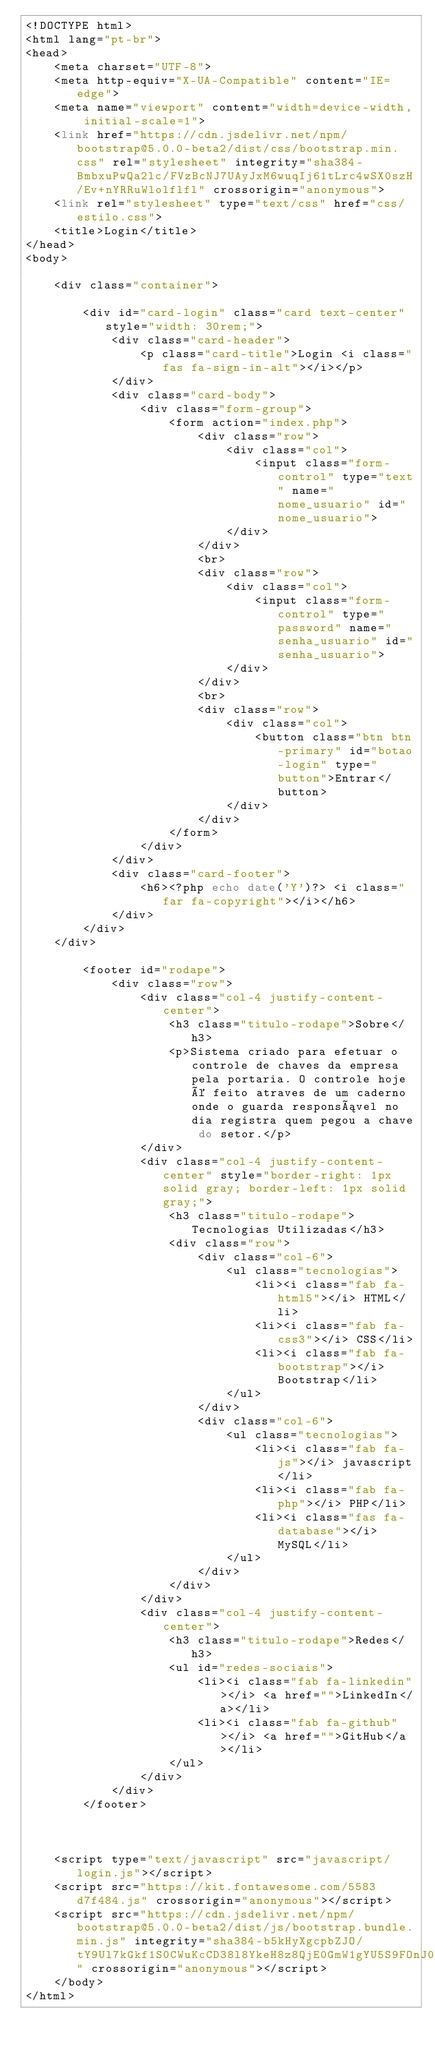Convert code to text. <code><loc_0><loc_0><loc_500><loc_500><_PHP_><!DOCTYPE html>
<html lang="pt-br">
<head>
    <meta charset="UTF-8">
    <meta http-equiv="X-UA-Compatible" content="IE=edge">
    <meta name="viewport" content="width=device-width, initial-scale=1">
    <link href="https://cdn.jsdelivr.net/npm/bootstrap@5.0.0-beta2/dist/css/bootstrap.min.css" rel="stylesheet" integrity="sha384-BmbxuPwQa2lc/FVzBcNJ7UAyJxM6wuqIj61tLrc4wSX0szH/Ev+nYRRuWlolflfl" crossorigin="anonymous">
    <link rel="stylesheet" type="text/css" href="css/estilo.css">
    <title>Login</title>
</head>
<body>

    <div class="container">

        <div id="card-login" class="card text-center" style="width: 30rem;">
            <div class="card-header">
                <p class="card-title">Login <i class="fas fa-sign-in-alt"></i></p>
            </div>
            <div class="card-body">
                <div class="form-group">
                    <form action="index.php">
                        <div class="row">
                            <div class="col">
                                <input class="form-control" type="text" name="nome_usuario" id="nome_usuario">
                            </div>
                        </div>
                        <br>
                        <div class="row">
                            <div class="col">
                                <input class="form-control" type="password" name="senha_usuario" id="senha_usuario">
                            </div>
                        </div>
                        <br>
                        <div class="row">
                            <div class="col">
                                <button class="btn btn-primary" id="botao-login" type="button">Entrar</button>
                            </div>
                        </div>
                    </form>
                </div>
            </div>
            <div class="card-footer">
                <h6><?php echo date('Y')?> <i class="far fa-copyright"></i></h6>
            </div>
        </div>
    </div>
        
        <footer id="rodape">
            <div class="row">
                <div class="col-4 justify-content-center">
                    <h3 class="titulo-rodape">Sobre</h3>
                    <p>Sistema criado para efetuar o controle de chaves da empresa pela portaria. O controle hoje é feito atraves de um caderno onde o guarda responsável no dia registra quem pegou a chave do setor.</p>
                </div>
                <div class="col-4 justify-content-center" style="border-right: 1px solid gray; border-left: 1px solid gray;">
                    <h3 class="titulo-rodape">Tecnologias Utilizadas</h3>
                    <div class="row">
                        <div class="col-6">
                            <ul class="tecnologias">
                                <li><i class="fab fa-html5"></i> HTML</li>
                                <li><i class="fab fa-css3"></i> CSS</li>
                                <li><i class="fab fa-bootstrap"></i> Bootstrap</li>
                            </ul>
                        </div>
                        <div class="col-6">
                            <ul class="tecnologias">
                                <li><i class="fab fa-js"></i> javascript</li>
                                <li><i class="fab fa-php"></i> PHP</li>
                                <li><i class="fas fa-database"></i> MySQL</li>
                            </ul>    
                        </div>
                    </div>
                </div>
                <div class="col-4 justify-content-center">
                    <h3 class="titulo-rodape">Redes</h3>
                    <ul id="redes-sociais">
                        <li><i class="fab fa-linkedin"></i> <a href="">LinkedIn</a></li>
                        <li><i class="fab fa-github"></i> <a href="">GitHub</a></li>
                    </ul>
                </div>
            </div>
        </footer>
    


    <script type="text/javascript" src="javascript/login.js"></script>
    <script src="https://kit.fontawesome.com/5583d7f484.js" crossorigin="anonymous"></script>
    <script src="https://cdn.jsdelivr.net/npm/bootstrap@5.0.0-beta2/dist/js/bootstrap.bundle.min.js" integrity="sha384-b5kHyXgcpbZJO/tY9Ul7kGkf1S0CWuKcCD38l8YkeH8z8QjE0GmW1gYU5S9FOnJ0" crossorigin="anonymous"></script>
    </body>
</html></code> 